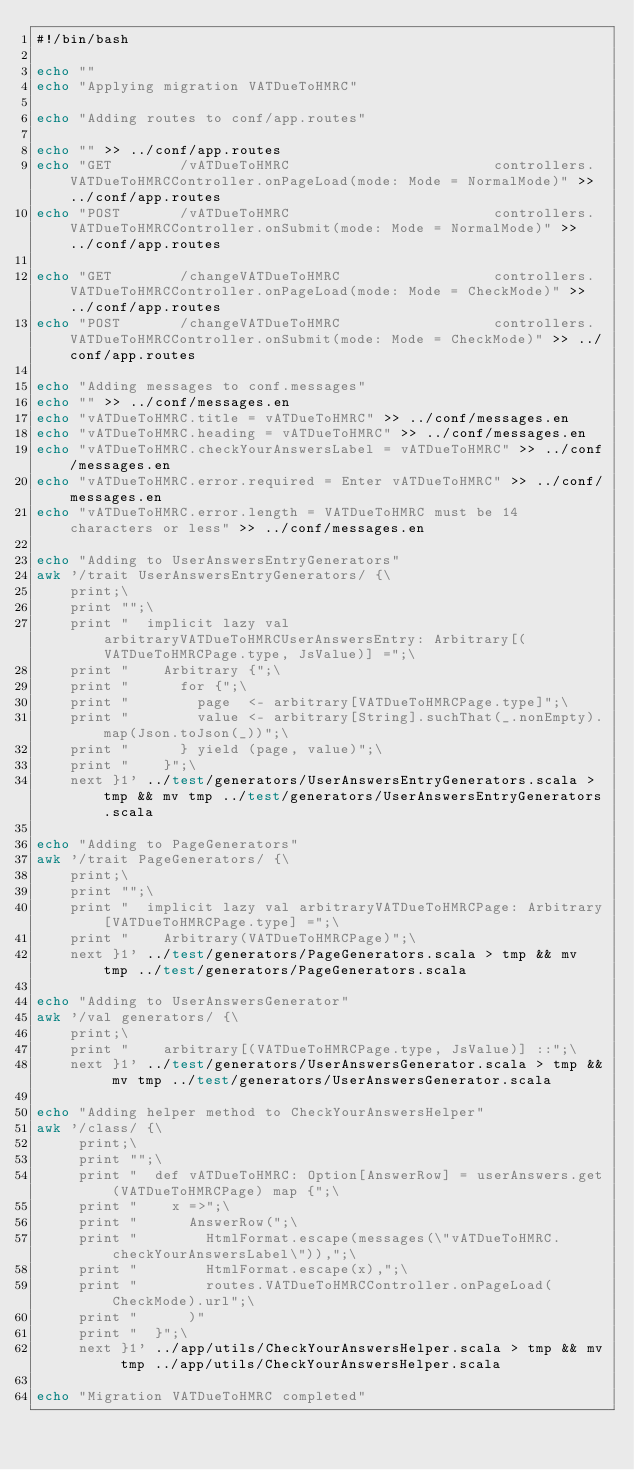Convert code to text. <code><loc_0><loc_0><loc_500><loc_500><_Bash_>#!/bin/bash

echo ""
echo "Applying migration VATDueToHMRC"

echo "Adding routes to conf/app.routes"

echo "" >> ../conf/app.routes
echo "GET        /vATDueToHMRC                        controllers.VATDueToHMRCController.onPageLoad(mode: Mode = NormalMode)" >> ../conf/app.routes
echo "POST       /vATDueToHMRC                        controllers.VATDueToHMRCController.onSubmit(mode: Mode = NormalMode)" >> ../conf/app.routes

echo "GET        /changeVATDueToHMRC                  controllers.VATDueToHMRCController.onPageLoad(mode: Mode = CheckMode)" >> ../conf/app.routes
echo "POST       /changeVATDueToHMRC                  controllers.VATDueToHMRCController.onSubmit(mode: Mode = CheckMode)" >> ../conf/app.routes

echo "Adding messages to conf.messages"
echo "" >> ../conf/messages.en
echo "vATDueToHMRC.title = vATDueToHMRC" >> ../conf/messages.en
echo "vATDueToHMRC.heading = vATDueToHMRC" >> ../conf/messages.en
echo "vATDueToHMRC.checkYourAnswersLabel = vATDueToHMRC" >> ../conf/messages.en
echo "vATDueToHMRC.error.required = Enter vATDueToHMRC" >> ../conf/messages.en
echo "vATDueToHMRC.error.length = VATDueToHMRC must be 14 characters or less" >> ../conf/messages.en

echo "Adding to UserAnswersEntryGenerators"
awk '/trait UserAnswersEntryGenerators/ {\
    print;\
    print "";\
    print "  implicit lazy val arbitraryVATDueToHMRCUserAnswersEntry: Arbitrary[(VATDueToHMRCPage.type, JsValue)] =";\
    print "    Arbitrary {";\
    print "      for {";\
    print "        page  <- arbitrary[VATDueToHMRCPage.type]";\
    print "        value <- arbitrary[String].suchThat(_.nonEmpty).map(Json.toJson(_))";\
    print "      } yield (page, value)";\
    print "    }";\
    next }1' ../test/generators/UserAnswersEntryGenerators.scala > tmp && mv tmp ../test/generators/UserAnswersEntryGenerators.scala

echo "Adding to PageGenerators"
awk '/trait PageGenerators/ {\
    print;\
    print "";\
    print "  implicit lazy val arbitraryVATDueToHMRCPage: Arbitrary[VATDueToHMRCPage.type] =";\
    print "    Arbitrary(VATDueToHMRCPage)";\
    next }1' ../test/generators/PageGenerators.scala > tmp && mv tmp ../test/generators/PageGenerators.scala

echo "Adding to UserAnswersGenerator"
awk '/val generators/ {\
    print;\
    print "    arbitrary[(VATDueToHMRCPage.type, JsValue)] ::";\
    next }1' ../test/generators/UserAnswersGenerator.scala > tmp && mv tmp ../test/generators/UserAnswersGenerator.scala

echo "Adding helper method to CheckYourAnswersHelper"
awk '/class/ {\
     print;\
     print "";\
     print "  def vATDueToHMRC: Option[AnswerRow] = userAnswers.get(VATDueToHMRCPage) map {";\
     print "    x =>";\
     print "      AnswerRow(";\
     print "        HtmlFormat.escape(messages(\"vATDueToHMRC.checkYourAnswersLabel\")),";\
     print "        HtmlFormat.escape(x),";\
     print "        routes.VATDueToHMRCController.onPageLoad(CheckMode).url";\
     print "      )"
     print "  }";\
     next }1' ../app/utils/CheckYourAnswersHelper.scala > tmp && mv tmp ../app/utils/CheckYourAnswersHelper.scala

echo "Migration VATDueToHMRC completed"
</code> 